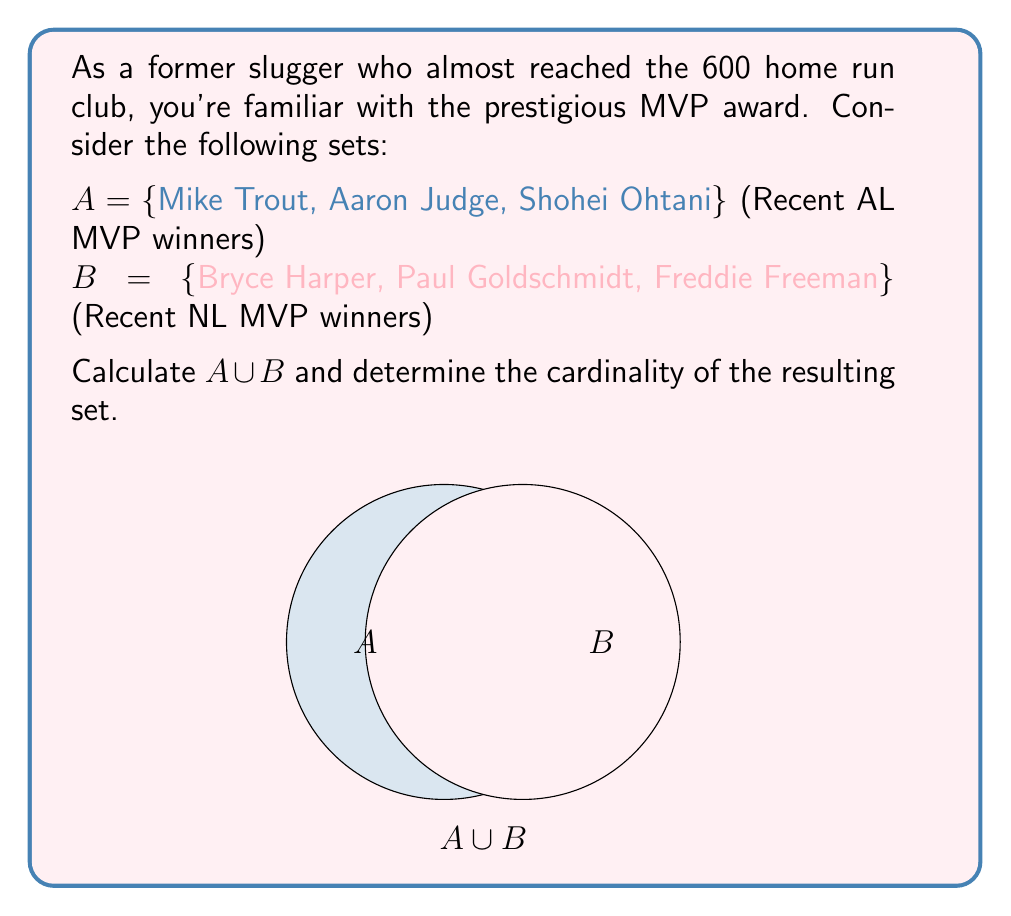What is the answer to this math problem? To solve this problem, let's follow these steps:

1) Recall that the union of two sets $A$ and $B$, denoted as $A \cup B$, is the set of all elements that are in $A$, in $B$, or in both.

2) In this case:
   $A = \{\text{Mike Trout, Aaron Judge, Shohei Ohtani}\}$
   $B = \{\text{Bryce Harper, Paul Goldschmidt, Freddie Freeman}\}$

3) Combining all unique elements from both sets:
   $A \cup B = \{\text{Mike Trout, Aaron Judge, Shohei Ohtani, Bryce Harper, Paul Goldschmidt, Freddie Freeman}\}$

4) To find the cardinality of $A \cup B$, we simply count the number of elements in the resulting set.

5) There are 6 unique players in $A \cup B$.

Therefore, the cardinality of $A \cup B$ is 6, which we can write as $|A \cup B| = 6$.
Answer: $|A \cup B| = 6$ 